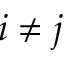<formula> <loc_0><loc_0><loc_500><loc_500>i \neq j</formula> 